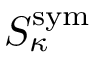Convert formula to latex. <formula><loc_0><loc_0><loc_500><loc_500>S _ { \kappa } ^ { s y m }</formula> 